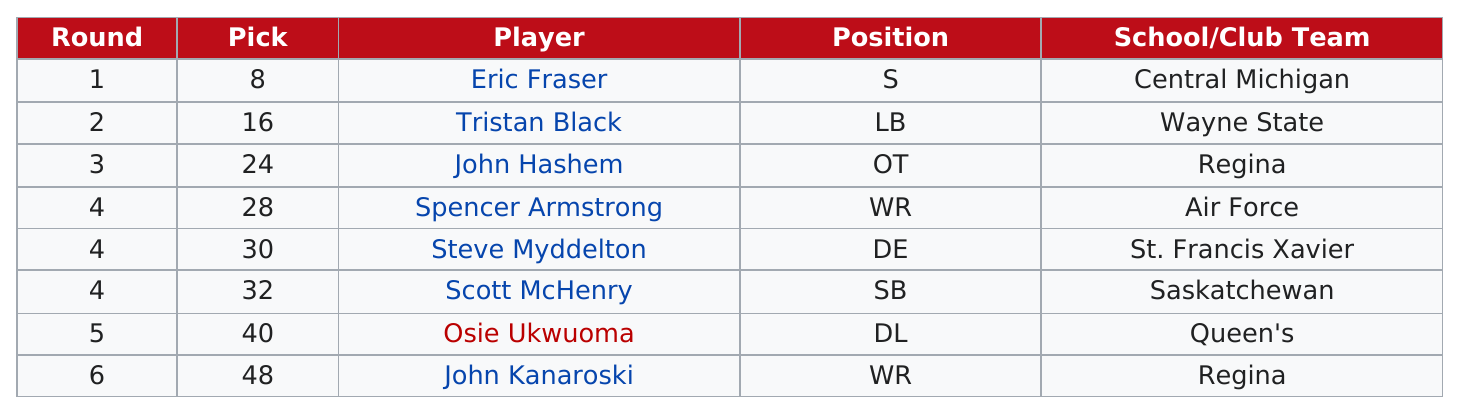Point out several critical features in this image. The last player selected was from Regina. In the fourth round, a total of three players were selected. According to this chart, 2 players held the position of Wide Receiver. There are 8 schools listed. The player with the position listed as "s" was named Eric Fraser. 